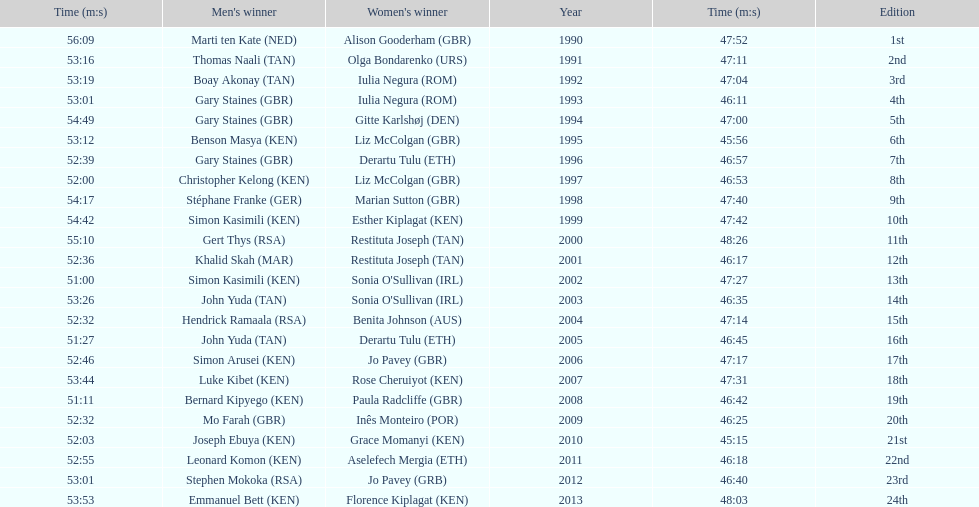Who were all the runners' times between 1990 and 2013? 47:52, 56:09, 47:11, 53:16, 47:04, 53:19, 46:11, 53:01, 47:00, 54:49, 45:56, 53:12, 46:57, 52:39, 46:53, 52:00, 47:40, 54:17, 47:42, 54:42, 48:26, 55:10, 46:17, 52:36, 47:27, 51:00, 46:35, 53:26, 47:14, 52:32, 46:45, 51:27, 47:17, 52:46, 47:31, 53:44, 46:42, 51:11, 46:25, 52:32, 45:15, 52:03, 46:18, 52:55, 46:40, 53:01, 48:03, 53:53. Which was the fastest time? 45:15. Who ran that time? Joseph Ebuya (KEN). 